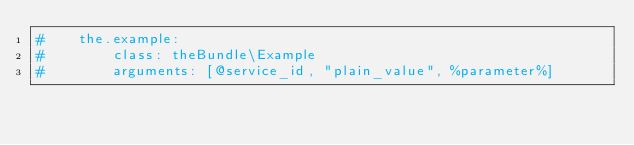Convert code to text. <code><loc_0><loc_0><loc_500><loc_500><_YAML_>#    the.example:
#        class: theBundle\Example
#        arguments: [@service_id, "plain_value", %parameter%]</code> 